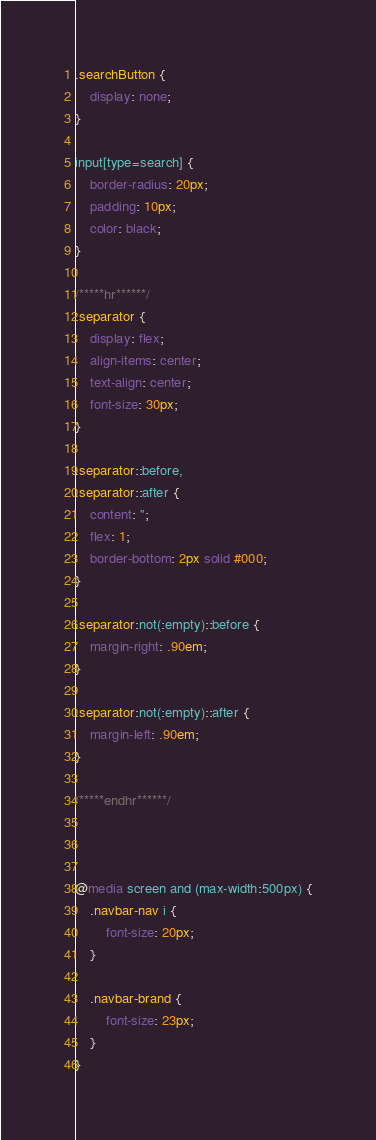Convert code to text. <code><loc_0><loc_0><loc_500><loc_500><_CSS_>.searchButton {
	display: none;
}

input[type=search] {
	border-radius: 20px;
	padding: 10px;
	color: black;
}

/*****hr******/
.separator {
	display: flex;
	align-items: center;
	text-align: center;
	font-size: 30px;
}

.separator::before,
.separator::after {
	content: '';
	flex: 1;
	border-bottom: 2px solid #000;
}

.separator:not(:empty)::before {
	margin-right: .90em;
}

.separator:not(:empty)::after {
	margin-left: .90em;
}

/*****endhr******/



@media screen and (max-width:500px) {
	.navbar-nav i {
		font-size: 20px;
	}

	.navbar-brand {
		font-size: 23px;
	}
}</code> 